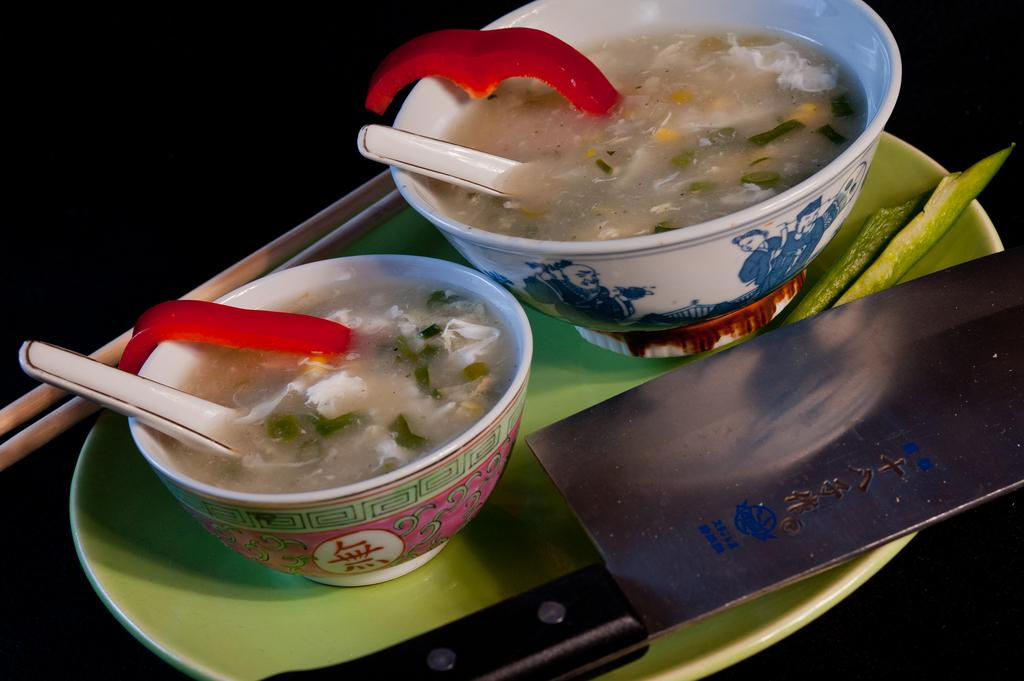What is located in the center of the image? There is a plate in the center of the image. What is placed on the plate? There is a knife on the plate, and there are bowls on the plate as well. What is inside the bowls on the plate? The bowls contain soup. What utensils are used for the soup? There are spoons in the soup. What can be observed about the background of the image? The background of the image is dark. What type of drug can be seen on the stove in the image? There is no stove or drug present in the image. 